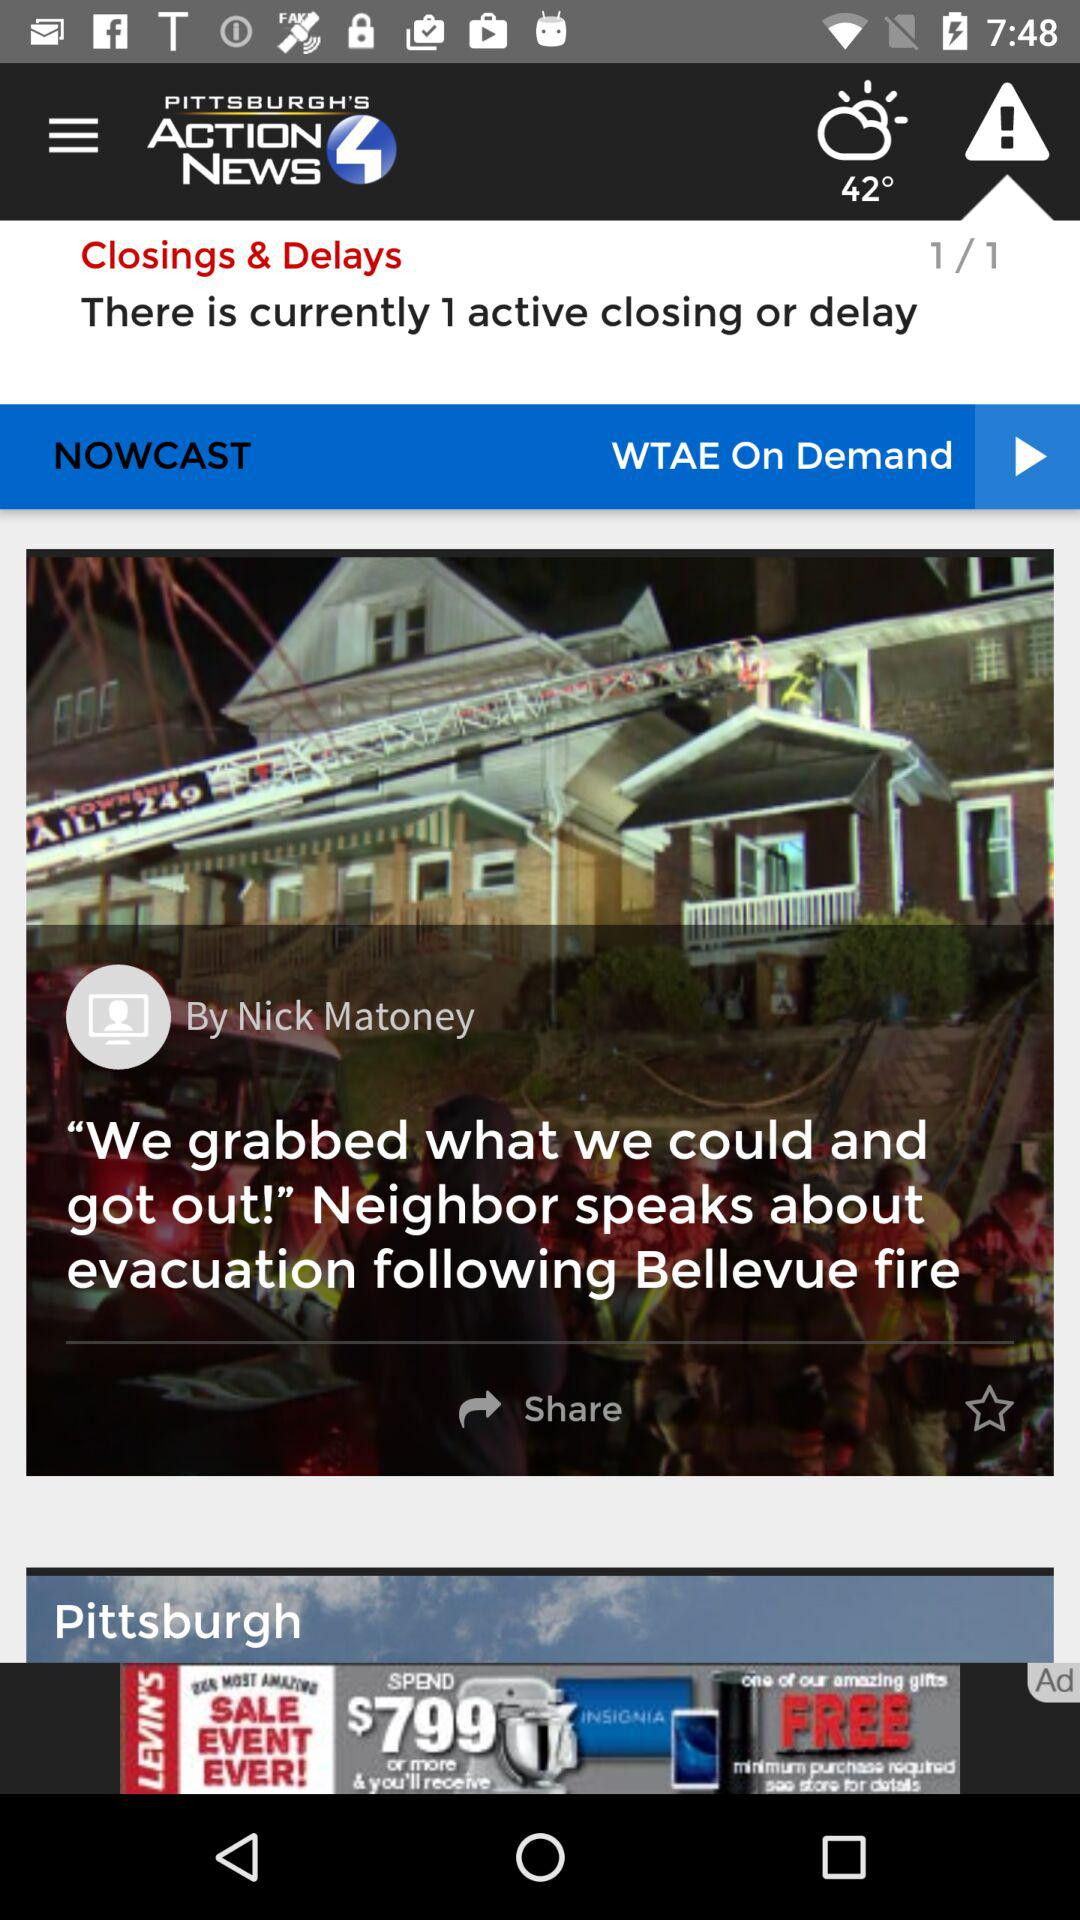Who is the author of the most recent news? The author is Nick Matoney. 